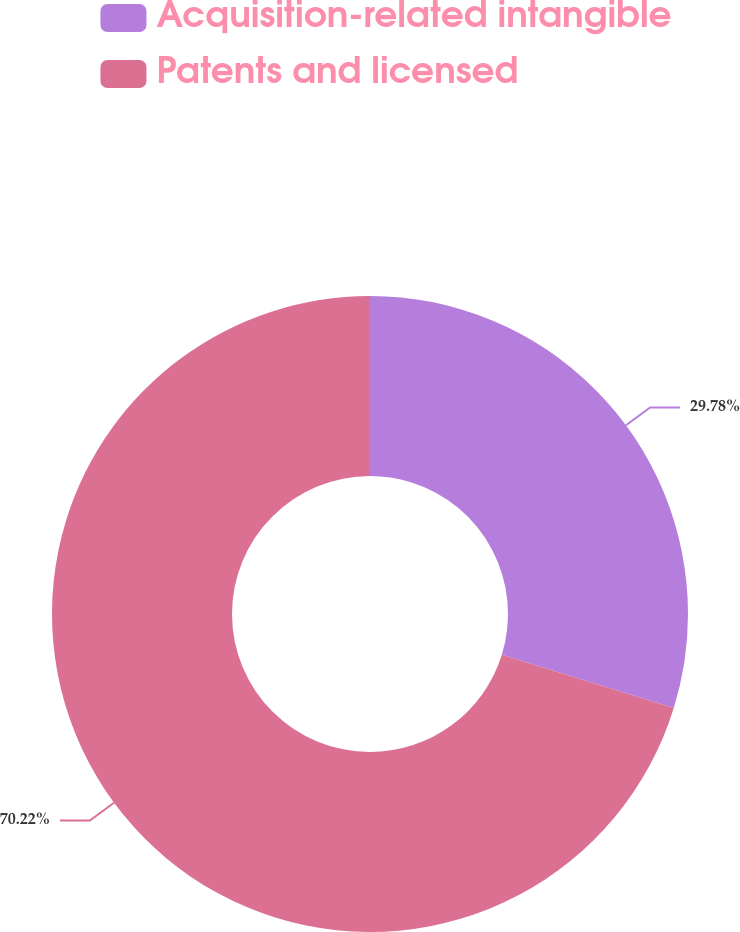<chart> <loc_0><loc_0><loc_500><loc_500><pie_chart><fcel>Acquisition-related intangible<fcel>Patents and licensed<nl><fcel>29.78%<fcel>70.22%<nl></chart> 